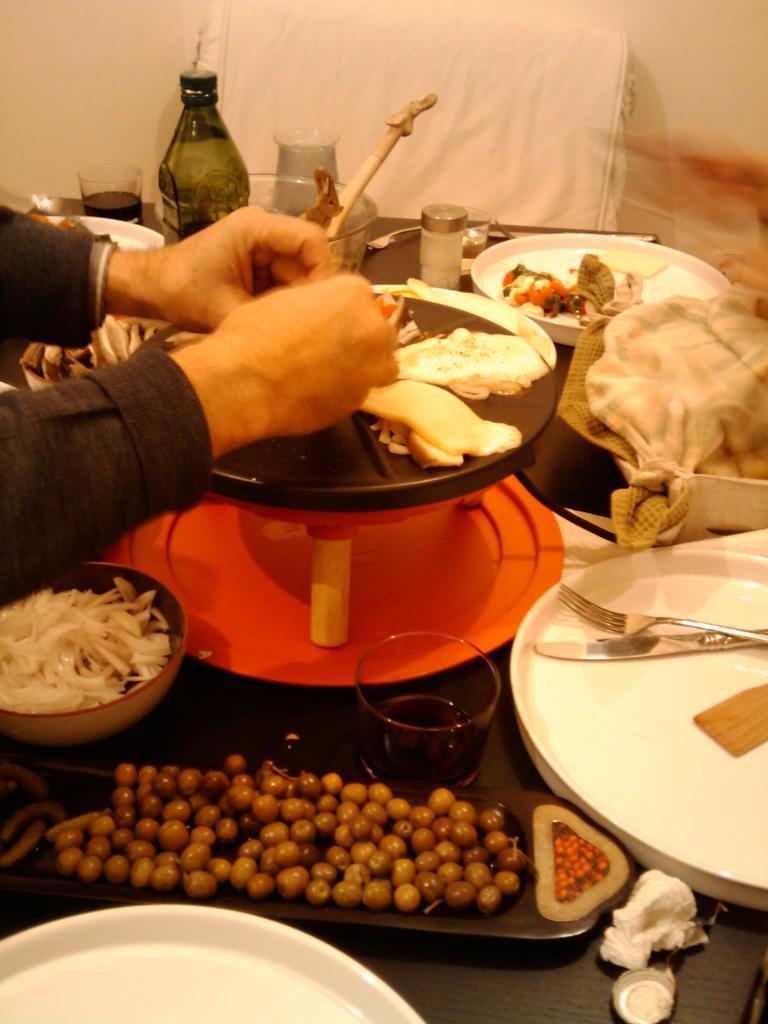Describe this image in one or two sentences. In this image there are some food items,spoons,forks,bottle,glasses on the table. 